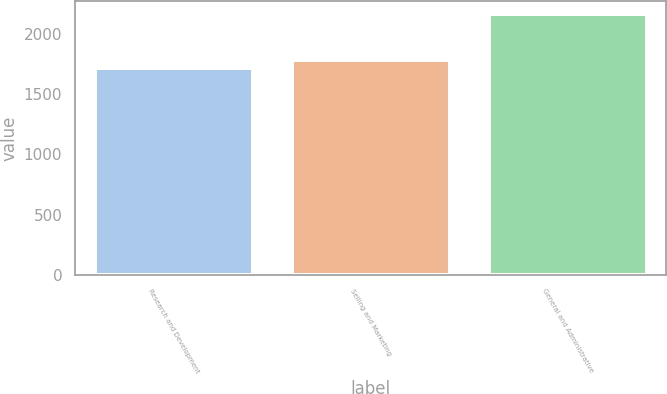Convert chart. <chart><loc_0><loc_0><loc_500><loc_500><bar_chart><fcel>Research and Development<fcel>Selling and Marketing<fcel>General and Administrative<nl><fcel>1722<fcel>1783<fcel>2167<nl></chart> 